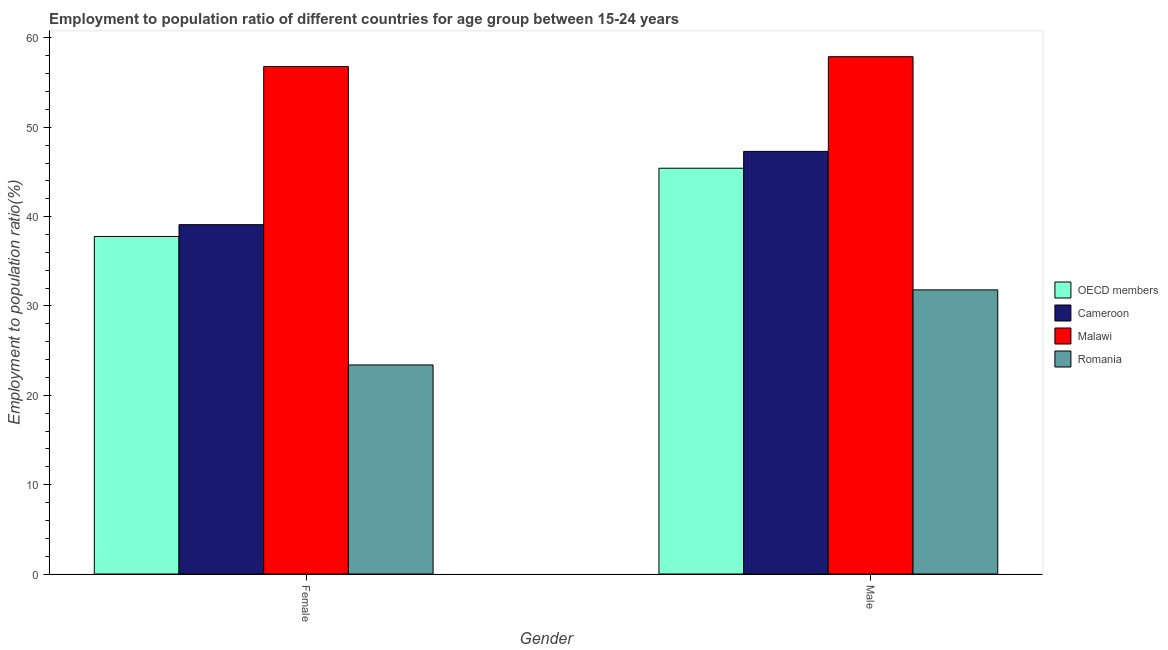Are the number of bars on each tick of the X-axis equal?
Give a very brief answer. Yes. How many bars are there on the 1st tick from the left?
Make the answer very short. 4. What is the label of the 2nd group of bars from the left?
Provide a short and direct response. Male. What is the employment to population ratio(female) in Malawi?
Your answer should be very brief. 56.8. Across all countries, what is the maximum employment to population ratio(female)?
Offer a terse response. 56.8. Across all countries, what is the minimum employment to population ratio(male)?
Ensure brevity in your answer.  31.8. In which country was the employment to population ratio(male) maximum?
Keep it short and to the point. Malawi. In which country was the employment to population ratio(male) minimum?
Provide a short and direct response. Romania. What is the total employment to population ratio(male) in the graph?
Provide a succinct answer. 182.42. What is the difference between the employment to population ratio(male) in OECD members and that in Malawi?
Offer a terse response. -12.48. What is the difference between the employment to population ratio(male) in Romania and the employment to population ratio(female) in OECD members?
Keep it short and to the point. -5.98. What is the average employment to population ratio(male) per country?
Your answer should be very brief. 45.6. What is the difference between the employment to population ratio(male) and employment to population ratio(female) in OECD members?
Provide a short and direct response. 7.64. In how many countries, is the employment to population ratio(male) greater than 38 %?
Give a very brief answer. 3. What is the ratio of the employment to population ratio(female) in Malawi to that in Cameroon?
Your answer should be very brief. 1.45. Is the employment to population ratio(female) in Romania less than that in Malawi?
Offer a very short reply. Yes. In how many countries, is the employment to population ratio(female) greater than the average employment to population ratio(female) taken over all countries?
Ensure brevity in your answer.  1. What does the 3rd bar from the left in Male represents?
Make the answer very short. Malawi. What does the 3rd bar from the right in Female represents?
Give a very brief answer. Cameroon. Are all the bars in the graph horizontal?
Make the answer very short. No. Are the values on the major ticks of Y-axis written in scientific E-notation?
Offer a terse response. No. Does the graph contain any zero values?
Your answer should be compact. No. Does the graph contain grids?
Your answer should be compact. No. How many legend labels are there?
Make the answer very short. 4. How are the legend labels stacked?
Ensure brevity in your answer.  Vertical. What is the title of the graph?
Provide a succinct answer. Employment to population ratio of different countries for age group between 15-24 years. What is the label or title of the Y-axis?
Provide a succinct answer. Employment to population ratio(%). What is the Employment to population ratio(%) of OECD members in Female?
Your answer should be very brief. 37.78. What is the Employment to population ratio(%) of Cameroon in Female?
Ensure brevity in your answer.  39.1. What is the Employment to population ratio(%) of Malawi in Female?
Offer a terse response. 56.8. What is the Employment to population ratio(%) in Romania in Female?
Provide a succinct answer. 23.4. What is the Employment to population ratio(%) in OECD members in Male?
Give a very brief answer. 45.42. What is the Employment to population ratio(%) in Cameroon in Male?
Make the answer very short. 47.3. What is the Employment to population ratio(%) in Malawi in Male?
Offer a terse response. 57.9. What is the Employment to population ratio(%) of Romania in Male?
Offer a terse response. 31.8. Across all Gender, what is the maximum Employment to population ratio(%) in OECD members?
Your answer should be very brief. 45.42. Across all Gender, what is the maximum Employment to population ratio(%) in Cameroon?
Provide a succinct answer. 47.3. Across all Gender, what is the maximum Employment to population ratio(%) of Malawi?
Your response must be concise. 57.9. Across all Gender, what is the maximum Employment to population ratio(%) in Romania?
Offer a terse response. 31.8. Across all Gender, what is the minimum Employment to population ratio(%) in OECD members?
Make the answer very short. 37.78. Across all Gender, what is the minimum Employment to population ratio(%) of Cameroon?
Offer a terse response. 39.1. Across all Gender, what is the minimum Employment to population ratio(%) in Malawi?
Give a very brief answer. 56.8. Across all Gender, what is the minimum Employment to population ratio(%) of Romania?
Keep it short and to the point. 23.4. What is the total Employment to population ratio(%) of OECD members in the graph?
Provide a succinct answer. 83.19. What is the total Employment to population ratio(%) of Cameroon in the graph?
Your answer should be compact. 86.4. What is the total Employment to population ratio(%) in Malawi in the graph?
Ensure brevity in your answer.  114.7. What is the total Employment to population ratio(%) in Romania in the graph?
Your answer should be very brief. 55.2. What is the difference between the Employment to population ratio(%) in OECD members in Female and that in Male?
Provide a succinct answer. -7.64. What is the difference between the Employment to population ratio(%) in Romania in Female and that in Male?
Give a very brief answer. -8.4. What is the difference between the Employment to population ratio(%) in OECD members in Female and the Employment to population ratio(%) in Cameroon in Male?
Your answer should be very brief. -9.52. What is the difference between the Employment to population ratio(%) of OECD members in Female and the Employment to population ratio(%) of Malawi in Male?
Provide a succinct answer. -20.12. What is the difference between the Employment to population ratio(%) of OECD members in Female and the Employment to population ratio(%) of Romania in Male?
Keep it short and to the point. 5.98. What is the difference between the Employment to population ratio(%) of Cameroon in Female and the Employment to population ratio(%) of Malawi in Male?
Offer a terse response. -18.8. What is the difference between the Employment to population ratio(%) of Cameroon in Female and the Employment to population ratio(%) of Romania in Male?
Your answer should be very brief. 7.3. What is the difference between the Employment to population ratio(%) in Malawi in Female and the Employment to population ratio(%) in Romania in Male?
Provide a short and direct response. 25. What is the average Employment to population ratio(%) in OECD members per Gender?
Your response must be concise. 41.6. What is the average Employment to population ratio(%) of Cameroon per Gender?
Your answer should be compact. 43.2. What is the average Employment to population ratio(%) in Malawi per Gender?
Your answer should be compact. 57.35. What is the average Employment to population ratio(%) in Romania per Gender?
Keep it short and to the point. 27.6. What is the difference between the Employment to population ratio(%) of OECD members and Employment to population ratio(%) of Cameroon in Female?
Give a very brief answer. -1.32. What is the difference between the Employment to population ratio(%) of OECD members and Employment to population ratio(%) of Malawi in Female?
Offer a very short reply. -19.02. What is the difference between the Employment to population ratio(%) of OECD members and Employment to population ratio(%) of Romania in Female?
Your response must be concise. 14.38. What is the difference between the Employment to population ratio(%) in Cameroon and Employment to population ratio(%) in Malawi in Female?
Offer a very short reply. -17.7. What is the difference between the Employment to population ratio(%) in Malawi and Employment to population ratio(%) in Romania in Female?
Ensure brevity in your answer.  33.4. What is the difference between the Employment to population ratio(%) in OECD members and Employment to population ratio(%) in Cameroon in Male?
Provide a short and direct response. -1.88. What is the difference between the Employment to population ratio(%) of OECD members and Employment to population ratio(%) of Malawi in Male?
Provide a succinct answer. -12.48. What is the difference between the Employment to population ratio(%) of OECD members and Employment to population ratio(%) of Romania in Male?
Keep it short and to the point. 13.62. What is the difference between the Employment to population ratio(%) of Cameroon and Employment to population ratio(%) of Malawi in Male?
Offer a terse response. -10.6. What is the difference between the Employment to population ratio(%) of Cameroon and Employment to population ratio(%) of Romania in Male?
Give a very brief answer. 15.5. What is the difference between the Employment to population ratio(%) in Malawi and Employment to population ratio(%) in Romania in Male?
Your answer should be compact. 26.1. What is the ratio of the Employment to population ratio(%) of OECD members in Female to that in Male?
Ensure brevity in your answer.  0.83. What is the ratio of the Employment to population ratio(%) of Cameroon in Female to that in Male?
Ensure brevity in your answer.  0.83. What is the ratio of the Employment to population ratio(%) in Romania in Female to that in Male?
Keep it short and to the point. 0.74. What is the difference between the highest and the second highest Employment to population ratio(%) of OECD members?
Offer a terse response. 7.64. What is the difference between the highest and the second highest Employment to population ratio(%) in Romania?
Offer a terse response. 8.4. What is the difference between the highest and the lowest Employment to population ratio(%) of OECD members?
Your response must be concise. 7.64. What is the difference between the highest and the lowest Employment to population ratio(%) of Cameroon?
Provide a succinct answer. 8.2. What is the difference between the highest and the lowest Employment to population ratio(%) of Romania?
Offer a terse response. 8.4. 